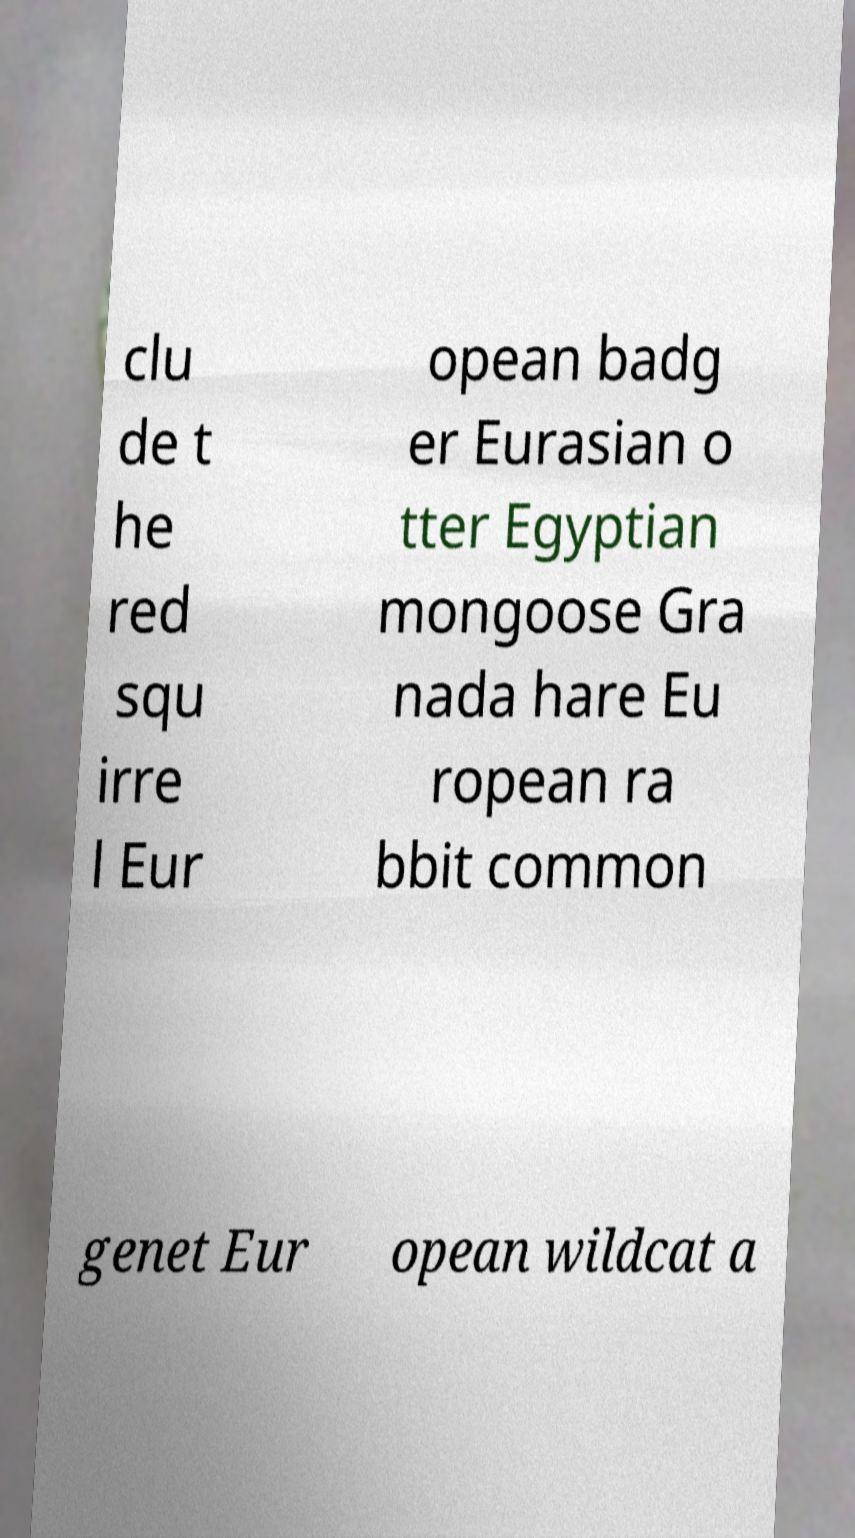Can you accurately transcribe the text from the provided image for me? clu de t he red squ irre l Eur opean badg er Eurasian o tter Egyptian mongoose Gra nada hare Eu ropean ra bbit common genet Eur opean wildcat a 